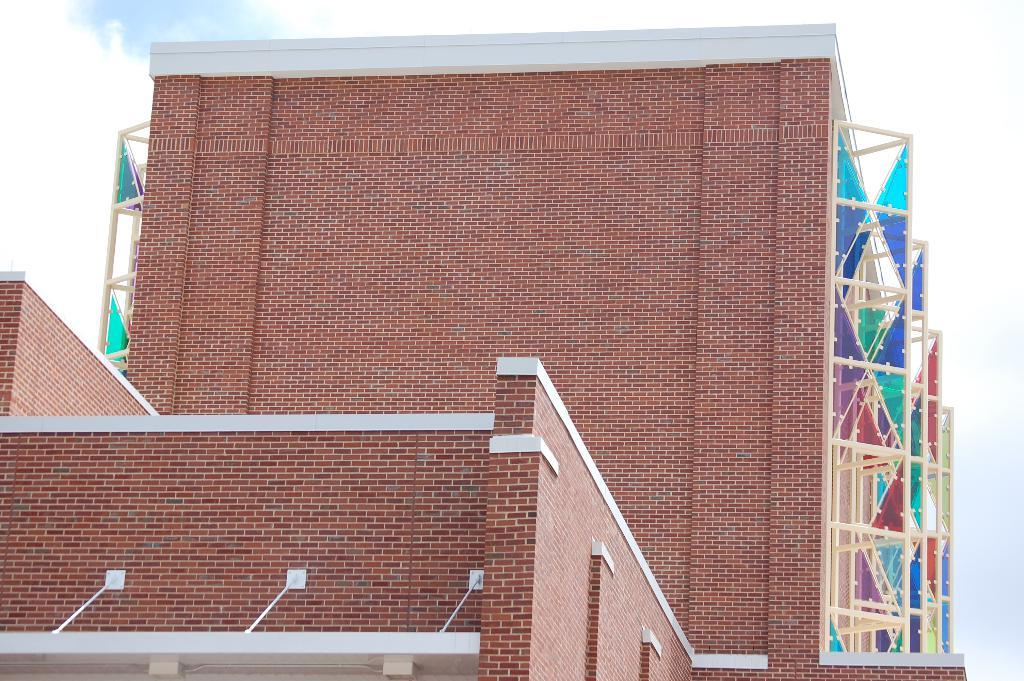What type of structures are present in the image? There are buildings in the image. What can be seen on either side of the buildings? There are frames on either side of the buildings. What is visible in the sky in the image? Clouds are visible in the sky. How many ants can be seen crawling on the buildings in the image? There are no ants visible in the image; it only shows buildings, frames, and clouds. 